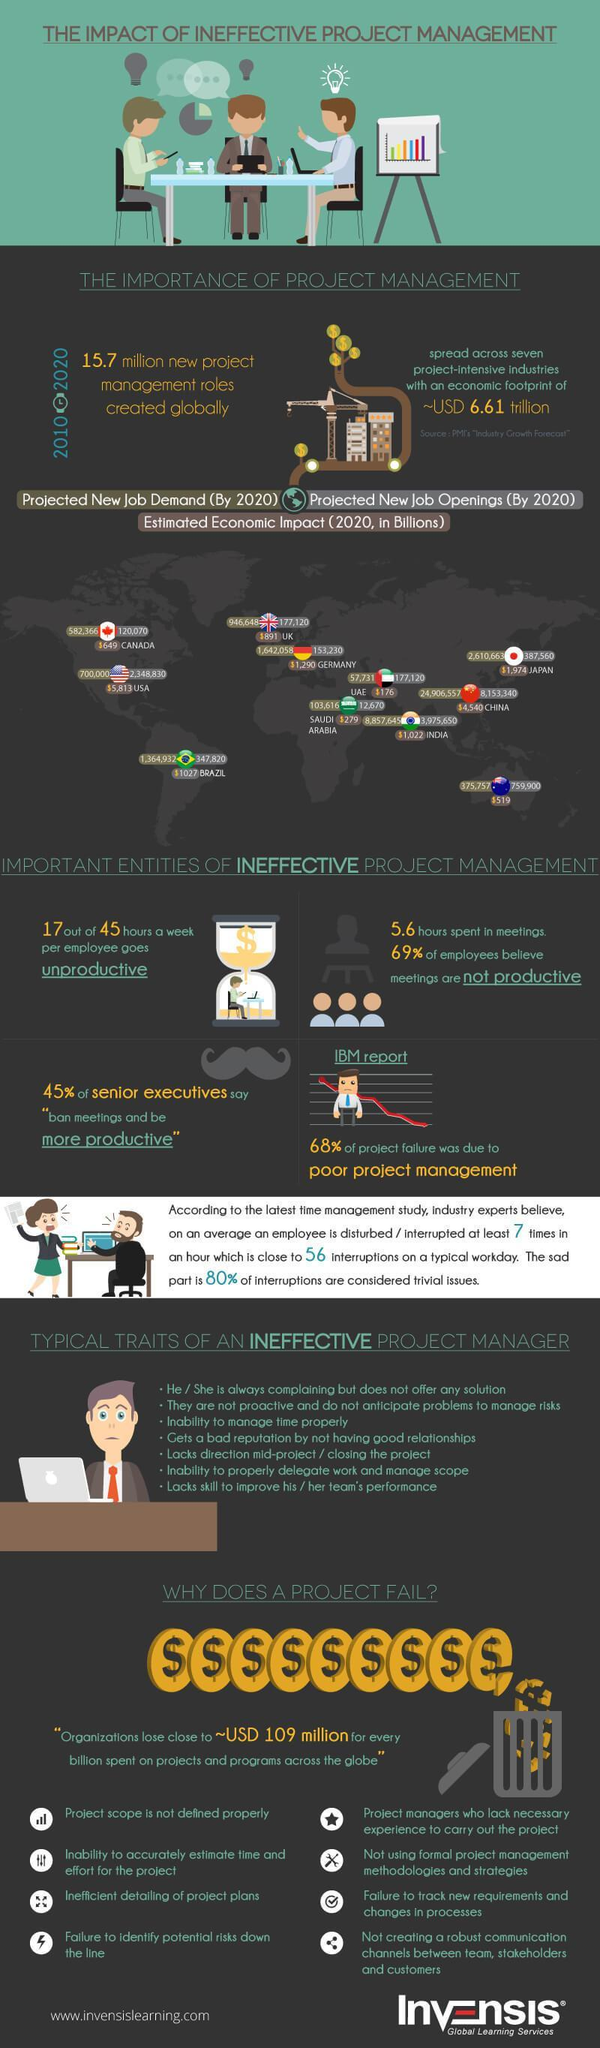What is the projected new job demand by 2020 in Canada?
Answer the question with a short phrase. 582,366 What is the difference in the projected new job demand in 2020 of US and UAE? 642,269 What is the difference in the economic impact in 2020 of China and India in billion dollars? 3518 What is the estimated economic impact in 2020 in India in billion dollars? 1022 What is the difference in the projected new job openings in 2020 of Japan and UK? 210,440 What is projected new job openings by 2020 in China? 8,153,340 